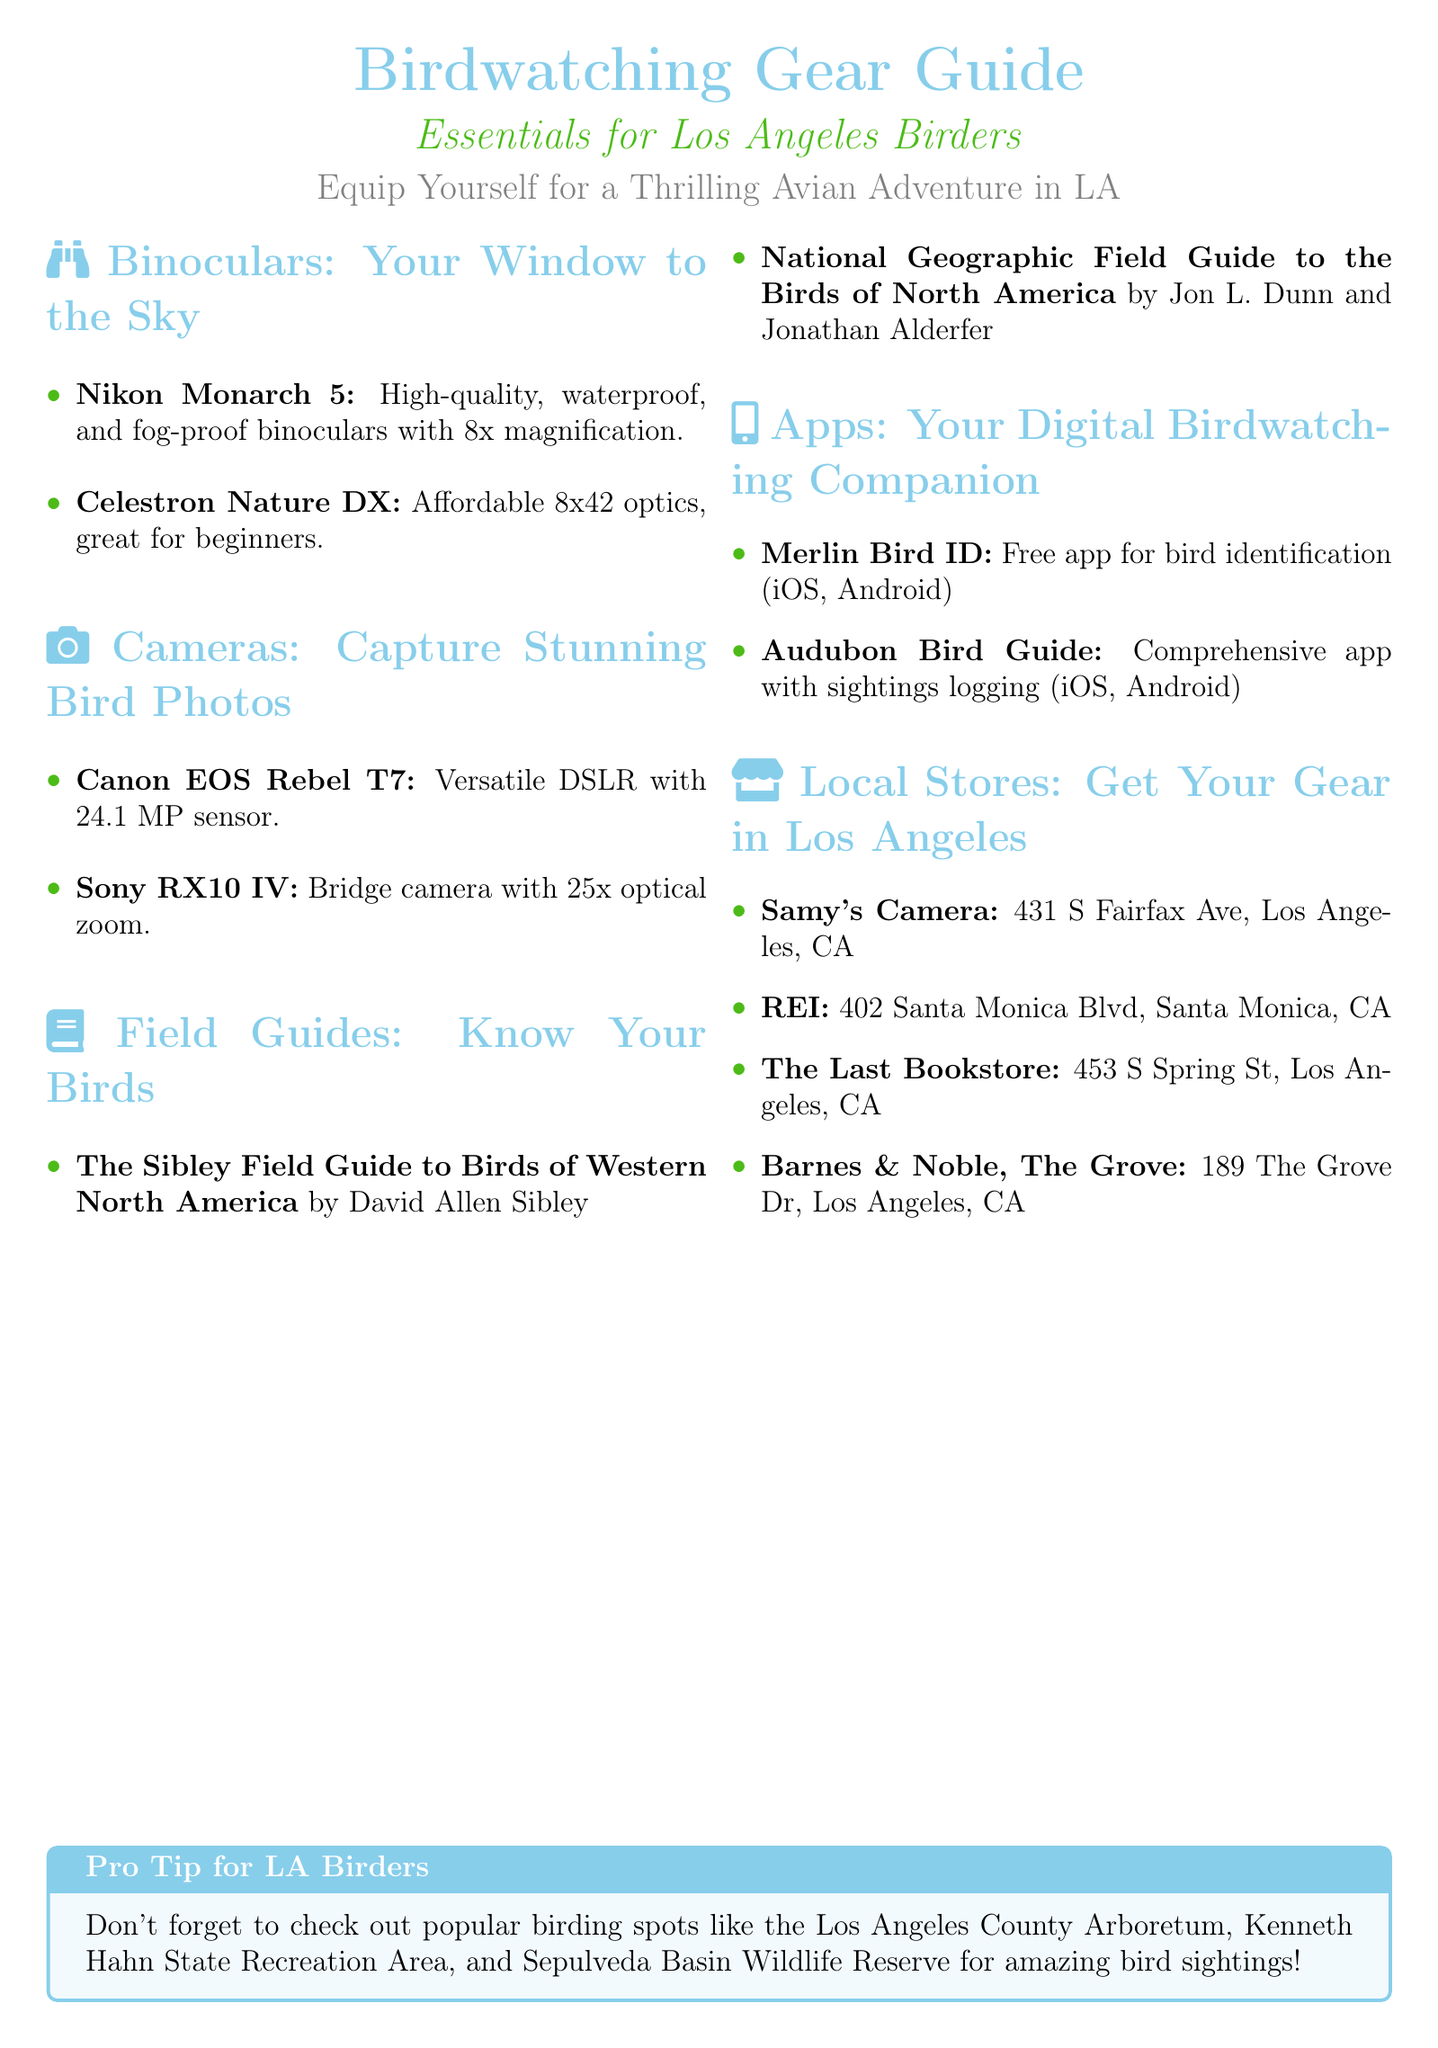What is the magnification of Nikon Monarch 5 binoculars? The Nikon Monarch 5 binoculars have 8x magnification.
Answer: 8x What is a recommended field guide for Western North America? The Sibley Field Guide to Birds of Western North America is recommended.
Answer: The Sibley Field Guide to Birds of Western North America Which app is free for bird identification? Merlin Bird ID is a free app for bird identification.
Answer: Merlin Bird ID Where is Samy's Camera located? Samy's Camera is located at 431 S Fairfax Ave, Los Angeles, CA.
Answer: 431 S Fairfax Ave, Los Angeles, CA What type of camera is the Canon EOS Rebel T7? The Canon EOS Rebel T7 is a versatile DSLR camera.
Answer: DSLR What is the total number of recommended local stores listed? The document lists four local stores for birdwatching gear in Los Angeles.
Answer: Four Which binoculars are affordable and great for beginners? Celestron Nature DX binoculars are affordable and great for beginners.
Answer: Celestron Nature DX What is the primary focus of the flyer? The flyer focuses on essential birdwatching gear for Los Angeles birders.
Answer: Essentials for Los Angeles Birders What device type does the Audubon Bird Guide app support? The Audubon Bird Guide app supports iOS and Android.
Answer: iOS, Android What feature does the Sony RX10 IV camera have? The Sony RX10 IV camera has 25x optical zoom.
Answer: 25x optical zoom 